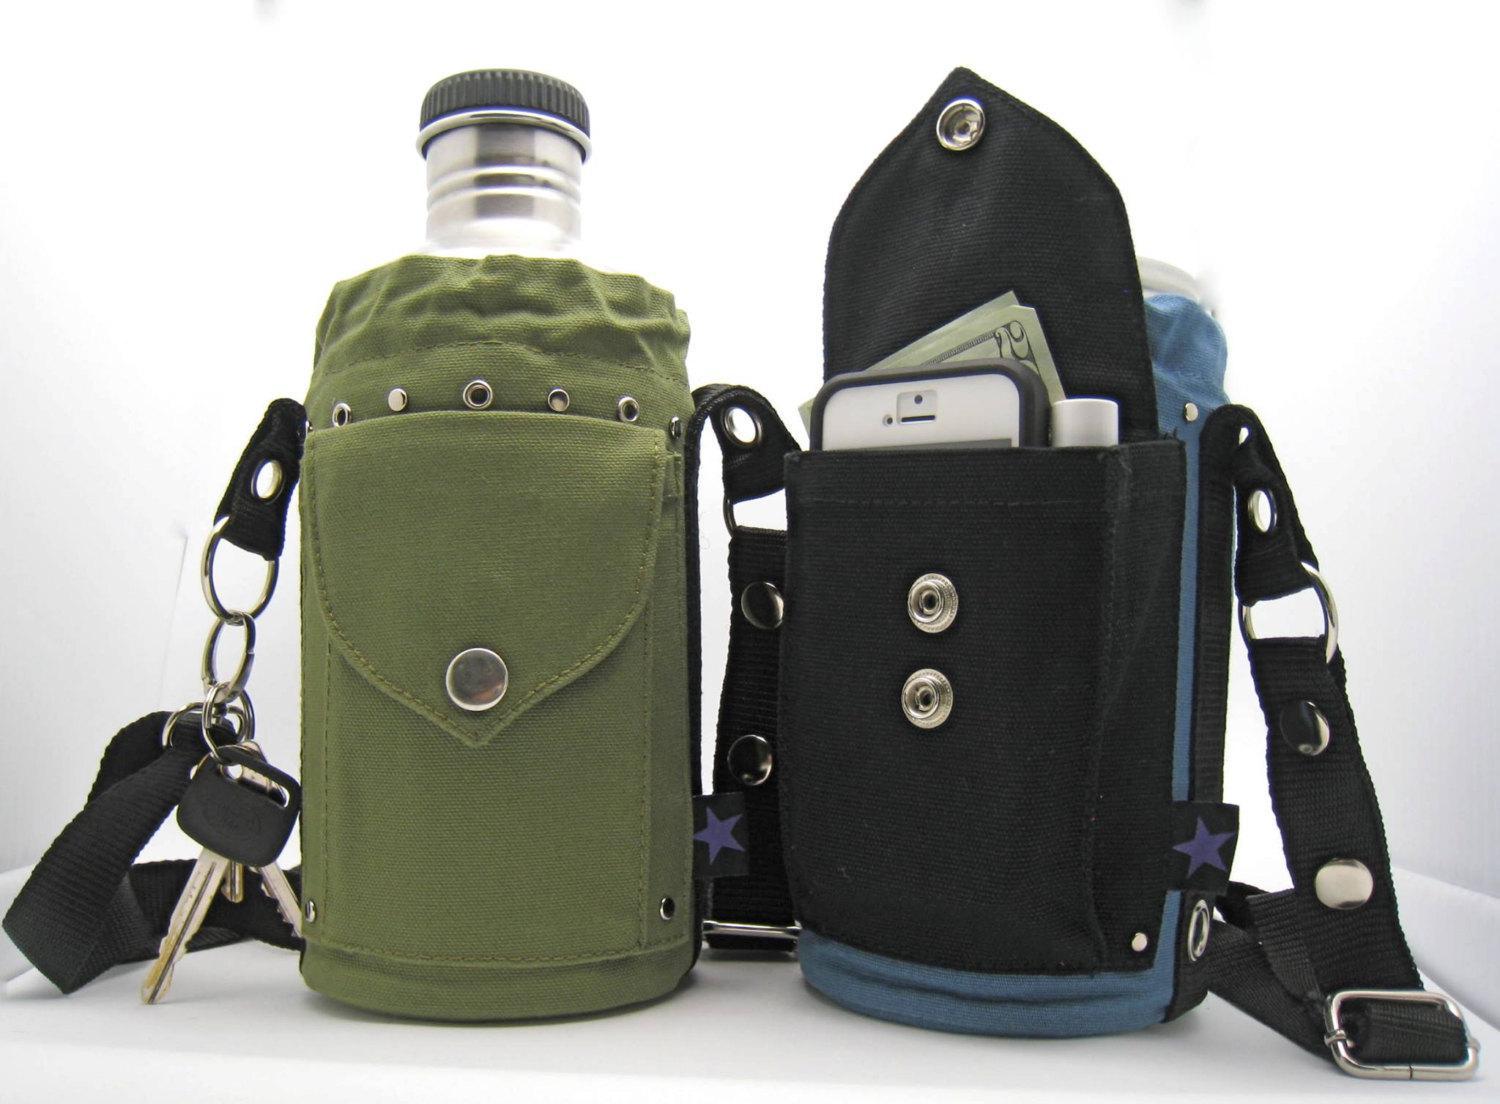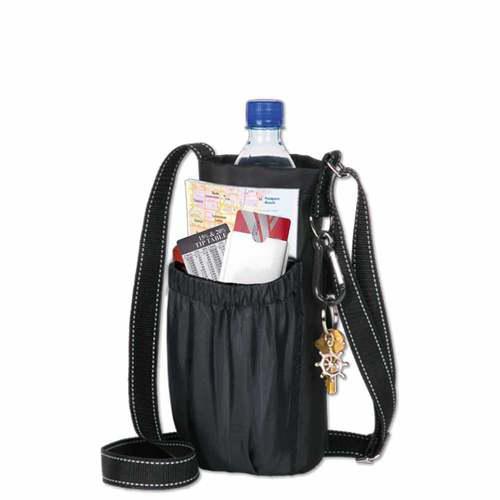The first image is the image on the left, the second image is the image on the right. For the images displayed, is the sentence "Right image includes a black bottle holder featuring a long strap and a pouch with an elasticized top, but the left image does not." factually correct? Answer yes or no. Yes. The first image is the image on the left, the second image is the image on the right. For the images shown, is this caption "A single bottle with a cap sits in a bag in each of the images." true? Answer yes or no. Yes. 